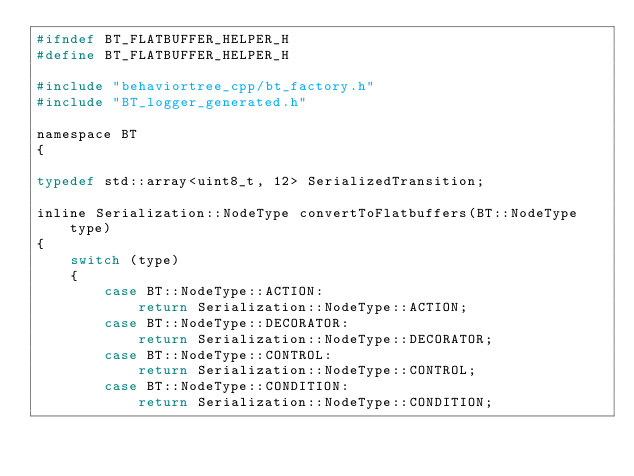Convert code to text. <code><loc_0><loc_0><loc_500><loc_500><_C_>#ifndef BT_FLATBUFFER_HELPER_H
#define BT_FLATBUFFER_HELPER_H

#include "behaviortree_cpp/bt_factory.h"
#include "BT_logger_generated.h"

namespace BT
{

typedef std::array<uint8_t, 12> SerializedTransition;

inline Serialization::NodeType convertToFlatbuffers(BT::NodeType type)
{
    switch (type)
    {
        case BT::NodeType::ACTION:
            return Serialization::NodeType::ACTION;
        case BT::NodeType::DECORATOR:
            return Serialization::NodeType::DECORATOR;
        case BT::NodeType::CONTROL:
            return Serialization::NodeType::CONTROL;
        case BT::NodeType::CONDITION:
            return Serialization::NodeType::CONDITION;</code> 